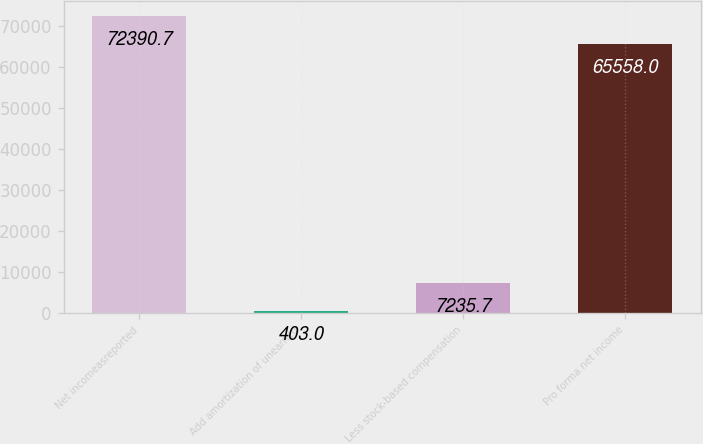<chart> <loc_0><loc_0><loc_500><loc_500><bar_chart><fcel>Net incomeasreported<fcel>Add amortization of unearned<fcel>Less stock-based compensation<fcel>Pro forma net income<nl><fcel>72390.7<fcel>403<fcel>7235.7<fcel>65558<nl></chart> 